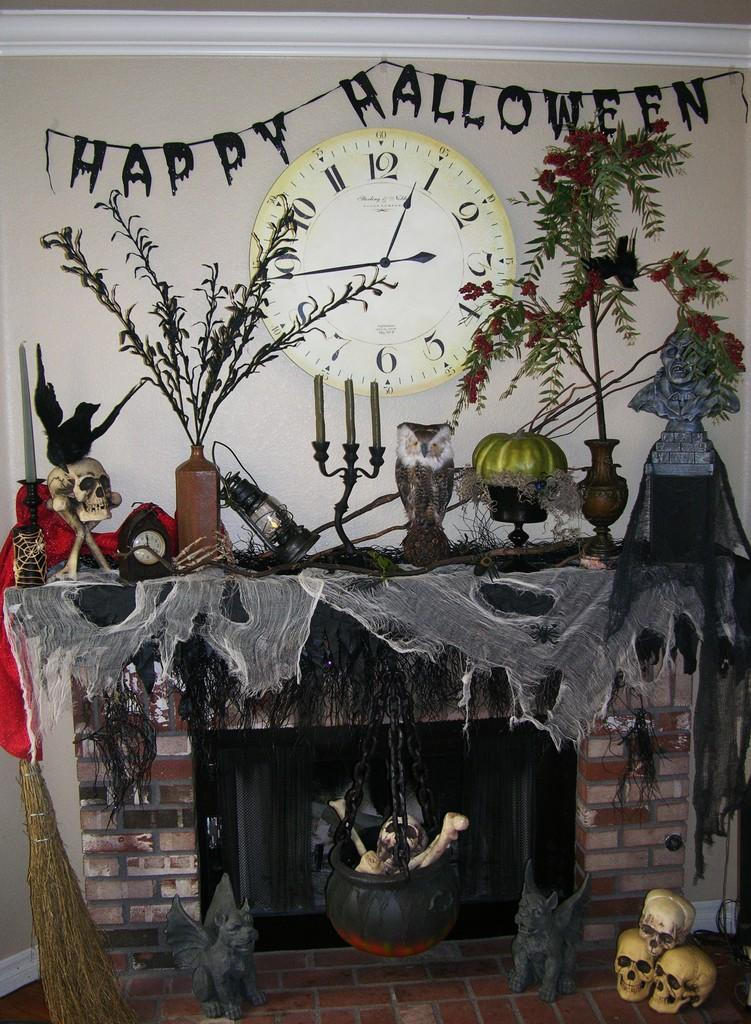<image>
Render a clear and concise summary of the photo. Halloween decorations surround a fireplace with the words Happy Halloween. 